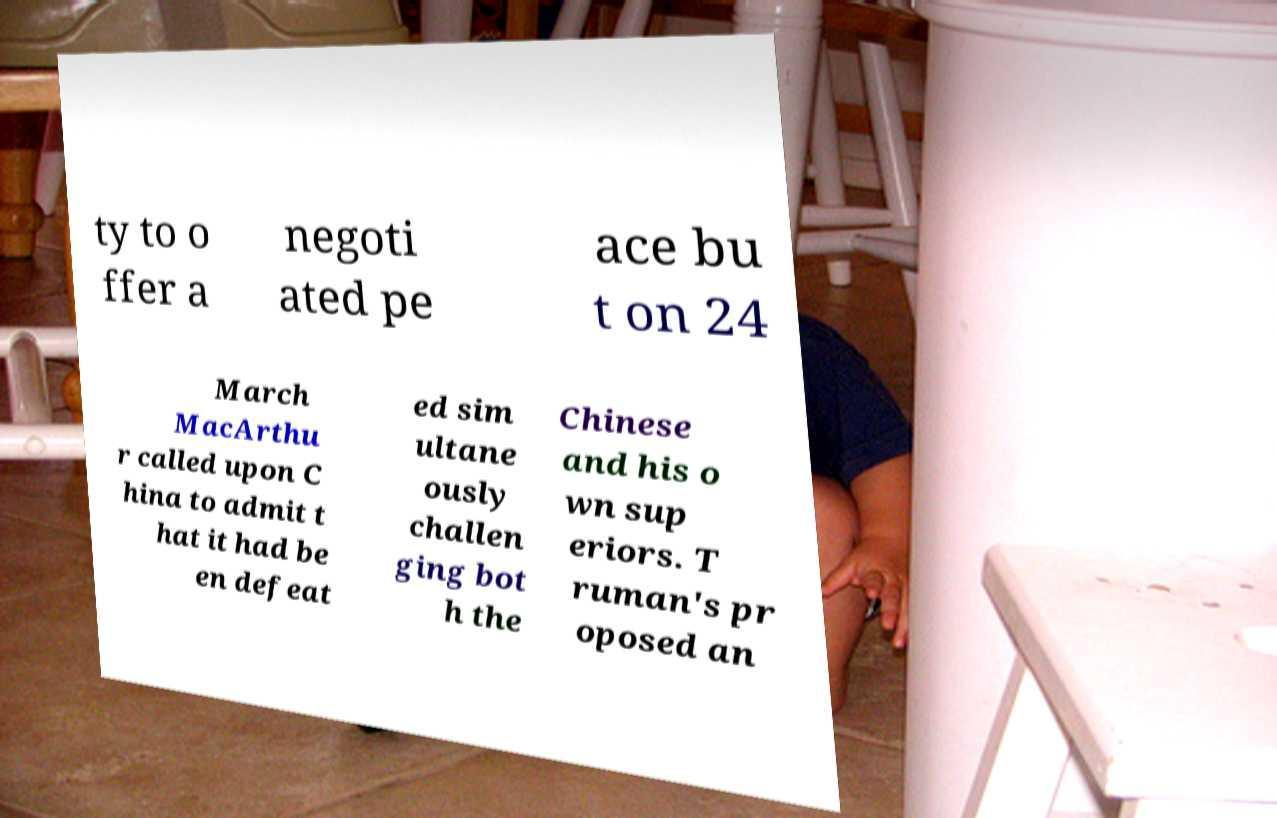Please identify and transcribe the text found in this image. ty to o ffer a negoti ated pe ace bu t on 24 March MacArthu r called upon C hina to admit t hat it had be en defeat ed sim ultane ously challen ging bot h the Chinese and his o wn sup eriors. T ruman's pr oposed an 